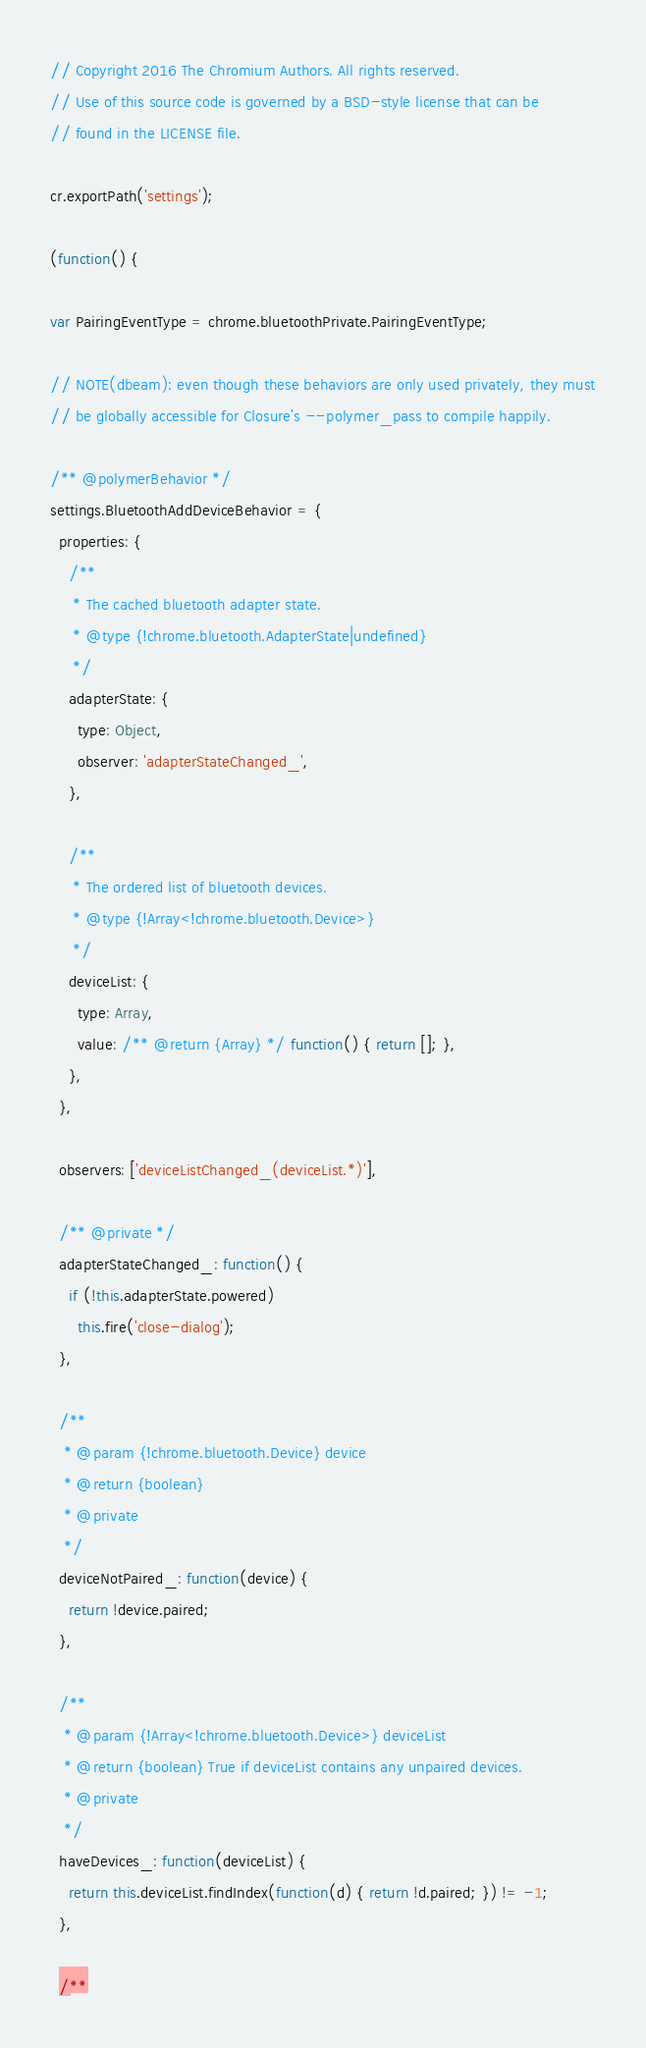<code> <loc_0><loc_0><loc_500><loc_500><_JavaScript_>// Copyright 2016 The Chromium Authors. All rights reserved.
// Use of this source code is governed by a BSD-style license that can be
// found in the LICENSE file.

cr.exportPath('settings');

(function() {

var PairingEventType = chrome.bluetoothPrivate.PairingEventType;

// NOTE(dbeam): even though these behaviors are only used privately, they must
// be globally accessible for Closure's --polymer_pass to compile happily.

/** @polymerBehavior */
settings.BluetoothAddDeviceBehavior = {
  properties: {
    /**
     * The cached bluetooth adapter state.
     * @type {!chrome.bluetooth.AdapterState|undefined}
     */
    adapterState: {
      type: Object,
      observer: 'adapterStateChanged_',
    },

    /**
     * The ordered list of bluetooth devices.
     * @type {!Array<!chrome.bluetooth.Device>}
     */
    deviceList: {
      type: Array,
      value: /** @return {Array} */ function() { return []; },
    },
  },

  observers: ['deviceListChanged_(deviceList.*)'],

  /** @private */
  adapterStateChanged_: function() {
    if (!this.adapterState.powered)
      this.fire('close-dialog');
  },

  /**
   * @param {!chrome.bluetooth.Device} device
   * @return {boolean}
   * @private
   */
  deviceNotPaired_: function(device) {
    return !device.paired;
  },

  /**
   * @param {!Array<!chrome.bluetooth.Device>} deviceList
   * @return {boolean} True if deviceList contains any unpaired devices.
   * @private
   */
  haveDevices_: function(deviceList) {
    return this.deviceList.findIndex(function(d) { return !d.paired; }) != -1;
  },

  /**</code> 